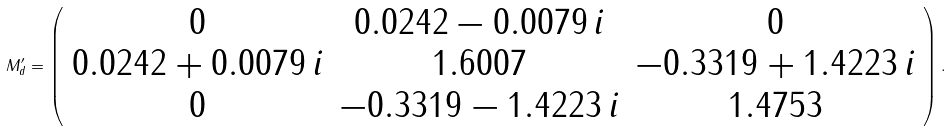Convert formula to latex. <formula><loc_0><loc_0><loc_500><loc_500>M ^ { \prime } _ { d } = \left ( \begin{array} { c c c } 0 & 0 . 0 2 4 2 - 0 . 0 0 7 9 \, i & 0 \\ 0 . 0 2 4 2 + 0 . 0 0 7 9 \, i & 1 . 6 0 0 7 & - 0 . 3 3 1 9 + 1 . 4 2 2 3 \, i \\ 0 & - 0 . 3 3 1 9 - 1 . 4 2 2 3 \, i & 1 . 4 7 5 3 \end{array} \right ) .</formula> 